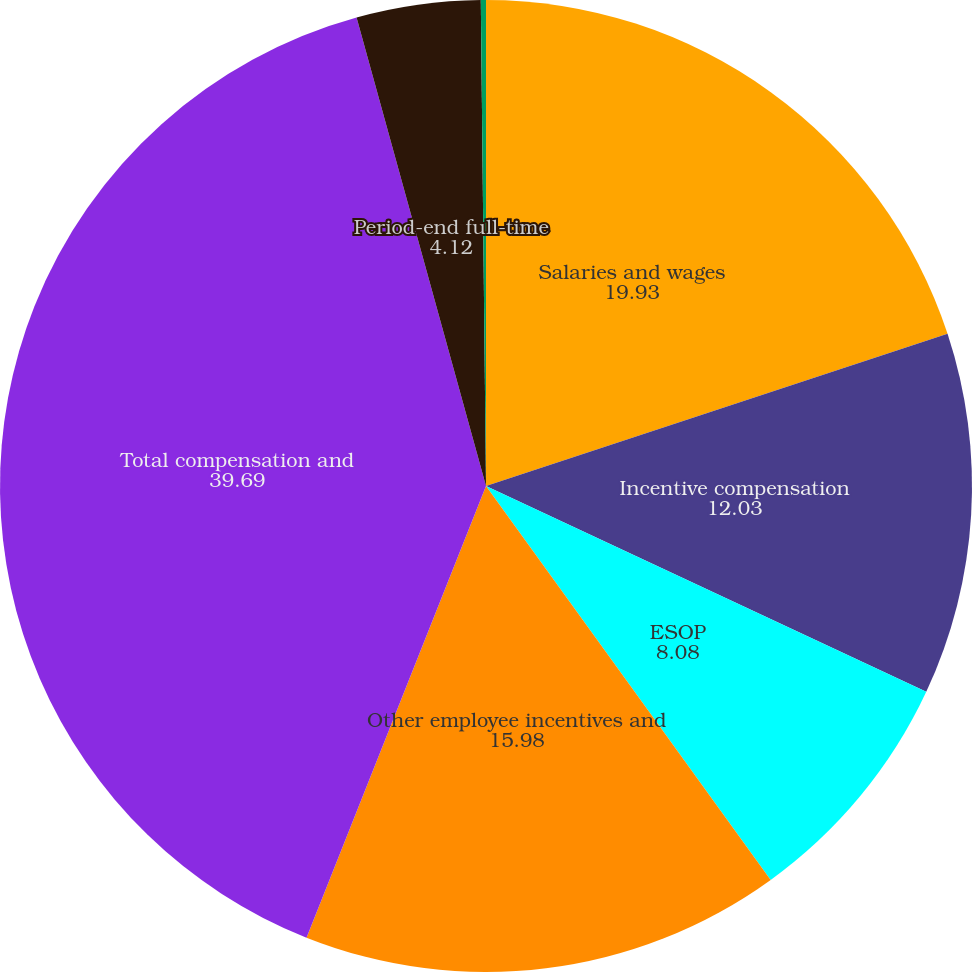<chart> <loc_0><loc_0><loc_500><loc_500><pie_chart><fcel>Salaries and wages<fcel>Incentive compensation<fcel>ESOP<fcel>Other employee incentives and<fcel>Total compensation and<fcel>Period-end full-time<fcel>Average full-time equivalent<nl><fcel>19.93%<fcel>12.03%<fcel>8.08%<fcel>15.98%<fcel>39.69%<fcel>4.12%<fcel>0.17%<nl></chart> 